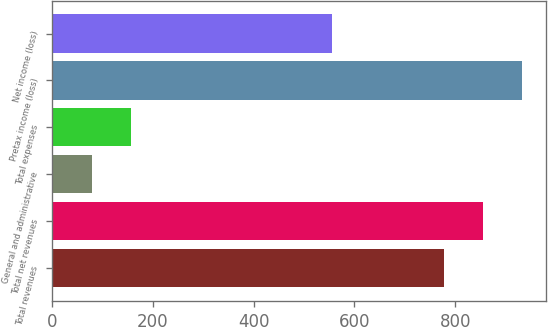<chart> <loc_0><loc_0><loc_500><loc_500><bar_chart><fcel>Total revenues<fcel>Total net revenues<fcel>General and administrative<fcel>Total expenses<fcel>Pretax income (loss)<fcel>Net income (loss)<nl><fcel>777<fcel>854.7<fcel>79<fcel>156.7<fcel>932.4<fcel>556<nl></chart> 